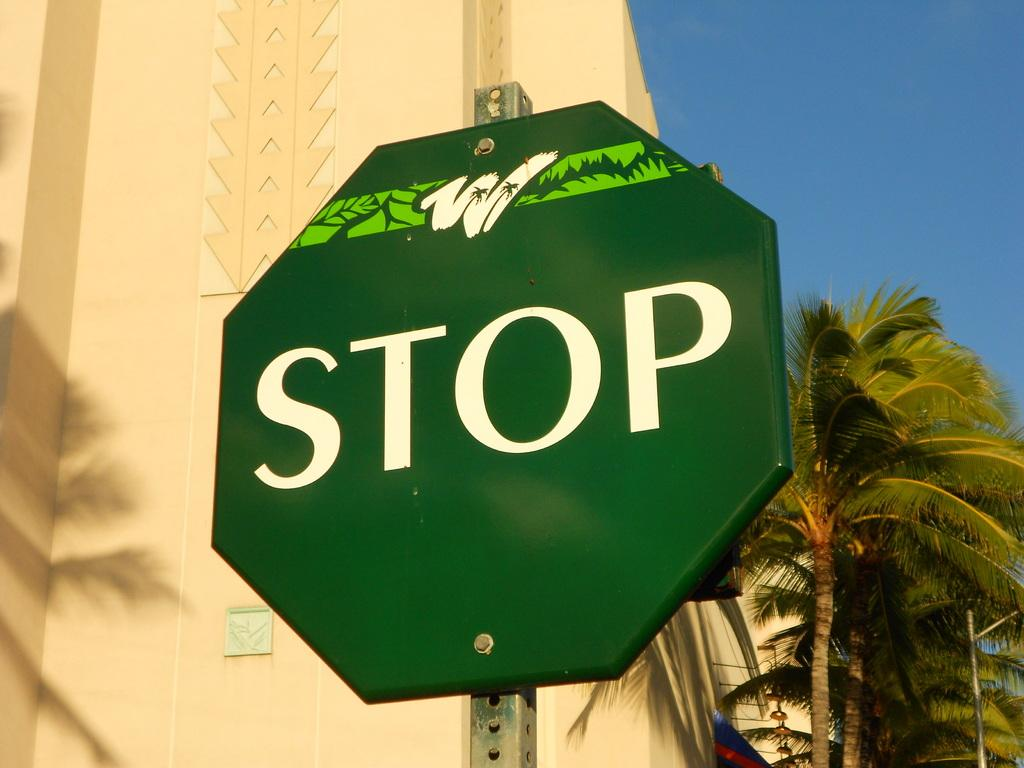<image>
Render a clear and concise summary of the photo. A green STOP sign with a white W with palm trees in it on the top 